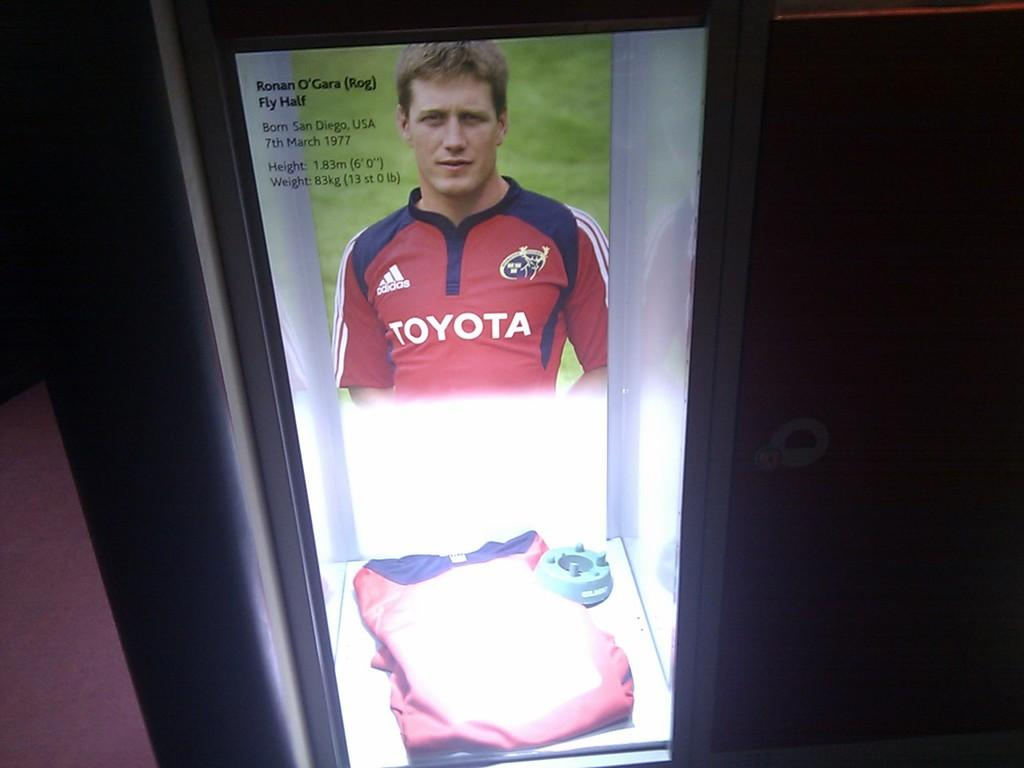<image>
Describe the image concisely. an ad featuring Ronan O'Gara who was born in San Diego, USA 